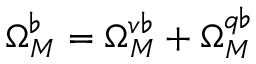Convert formula to latex. <formula><loc_0><loc_0><loc_500><loc_500>\Omega _ { M } ^ { \flat } = \Omega _ { M } ^ { v \flat } + \Omega _ { M } ^ { q \flat }</formula> 